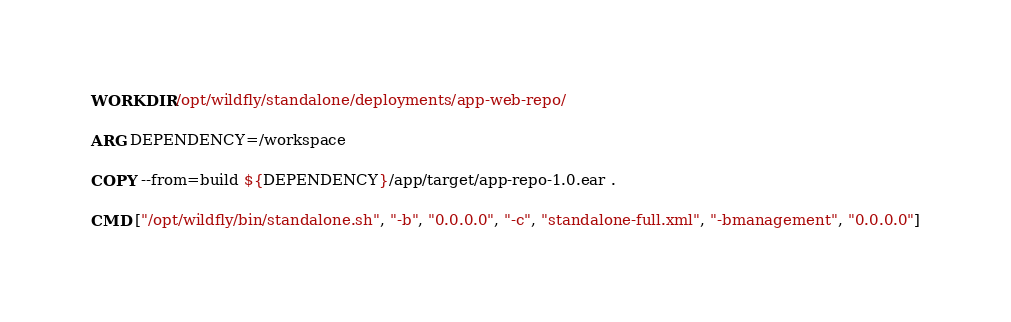<code> <loc_0><loc_0><loc_500><loc_500><_Dockerfile_>
WORKDIR /opt/wildfly/standalone/deployments/app-web-repo/

ARG DEPENDENCY=/workspace

COPY --from=build ${DEPENDENCY}/app/target/app-repo-1.0.ear .

CMD ["/opt/wildfly/bin/standalone.sh", "-b", "0.0.0.0", "-c", "standalone-full.xml", "-bmanagement", "0.0.0.0"]</code> 